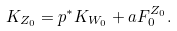Convert formula to latex. <formula><loc_0><loc_0><loc_500><loc_500>K _ { Z _ { 0 } } = p ^ { \ast } K _ { W _ { 0 } } + a F _ { 0 } ^ { Z _ { 0 } } .</formula> 